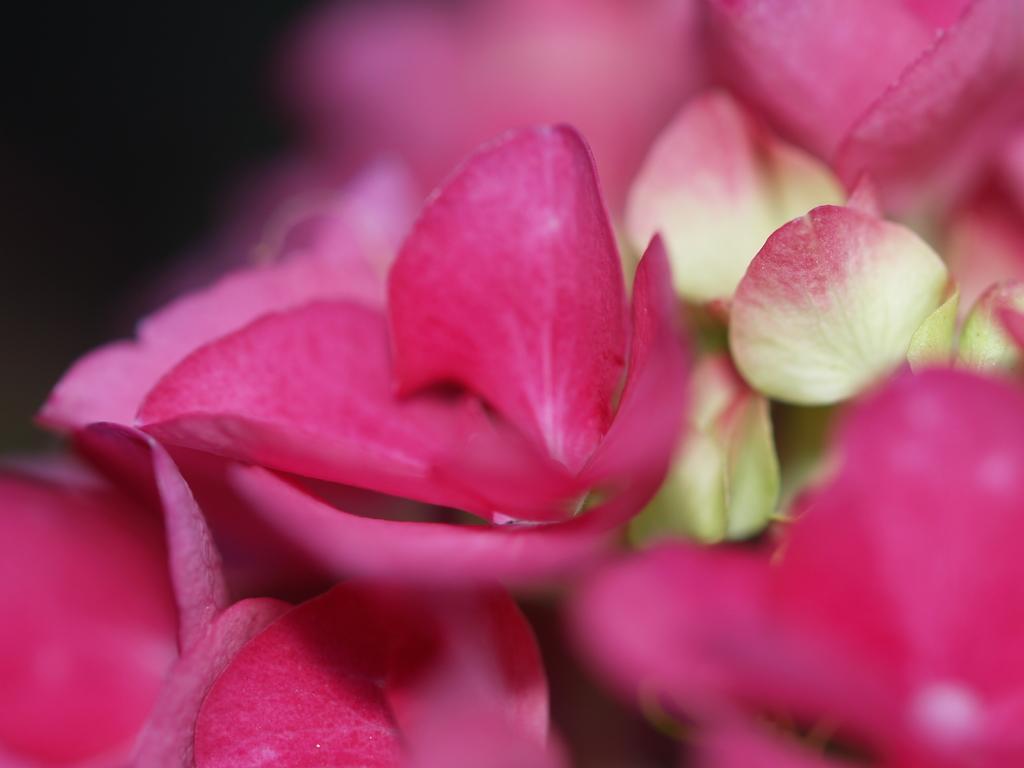Could you give a brief overview of what you see in this image? In this image we can see there are flowers and there is a dark background. 